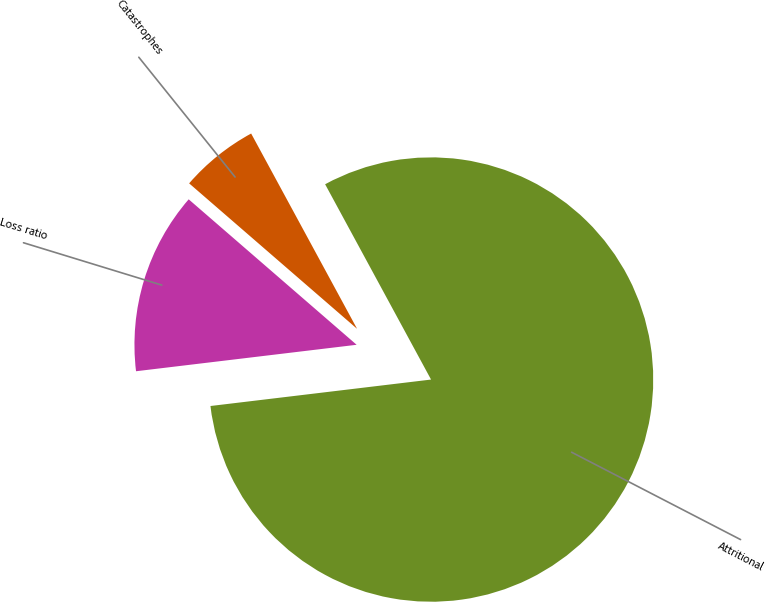Convert chart to OTSL. <chart><loc_0><loc_0><loc_500><loc_500><pie_chart><fcel>Attritional<fcel>Catastrophes<fcel>Loss ratio<nl><fcel>81.01%<fcel>5.73%<fcel>13.26%<nl></chart> 